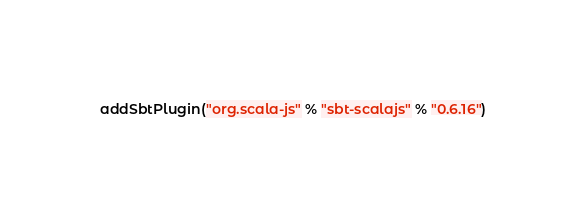<code> <loc_0><loc_0><loc_500><loc_500><_Scala_>addSbtPlugin("org.scala-js" % "sbt-scalajs" % "0.6.16")</code> 